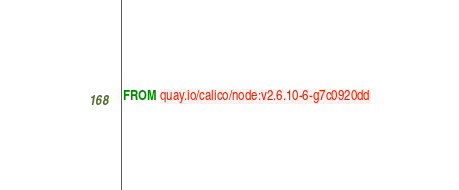<code> <loc_0><loc_0><loc_500><loc_500><_Dockerfile_>FROM quay.io/calico/node:v2.6.10-6-g7c0920dd
</code> 